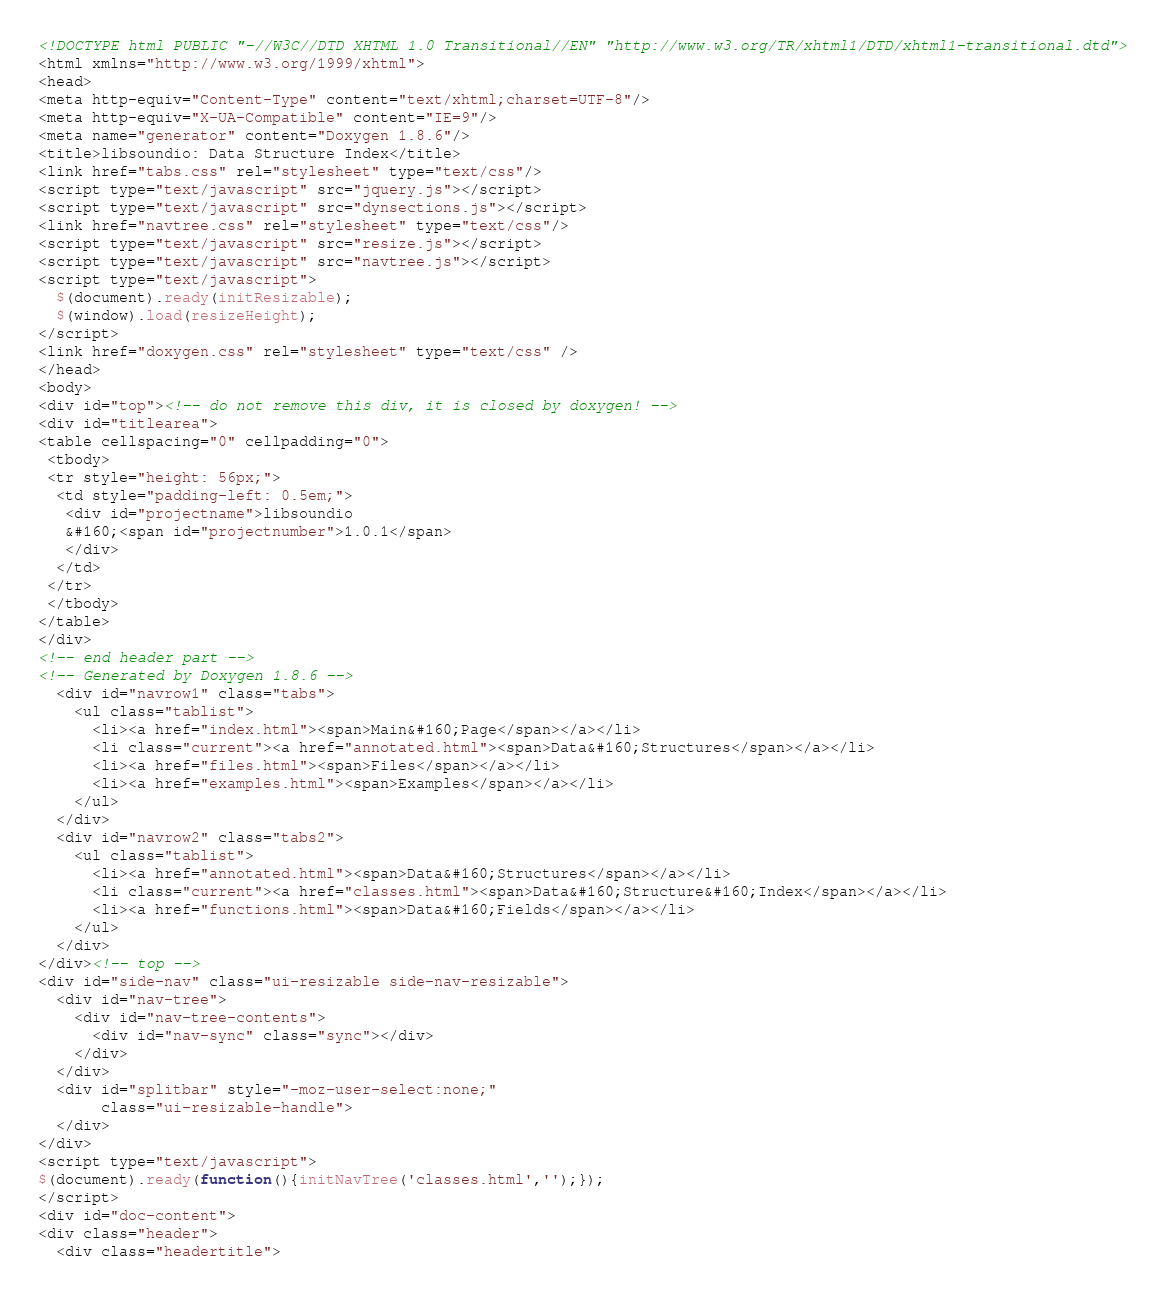<code> <loc_0><loc_0><loc_500><loc_500><_HTML_><!DOCTYPE html PUBLIC "-//W3C//DTD XHTML 1.0 Transitional//EN" "http://www.w3.org/TR/xhtml1/DTD/xhtml1-transitional.dtd">
<html xmlns="http://www.w3.org/1999/xhtml">
<head>
<meta http-equiv="Content-Type" content="text/xhtml;charset=UTF-8"/>
<meta http-equiv="X-UA-Compatible" content="IE=9"/>
<meta name="generator" content="Doxygen 1.8.6"/>
<title>libsoundio: Data Structure Index</title>
<link href="tabs.css" rel="stylesheet" type="text/css"/>
<script type="text/javascript" src="jquery.js"></script>
<script type="text/javascript" src="dynsections.js"></script>
<link href="navtree.css" rel="stylesheet" type="text/css"/>
<script type="text/javascript" src="resize.js"></script>
<script type="text/javascript" src="navtree.js"></script>
<script type="text/javascript">
  $(document).ready(initResizable);
  $(window).load(resizeHeight);
</script>
<link href="doxygen.css" rel="stylesheet" type="text/css" />
</head>
<body>
<div id="top"><!-- do not remove this div, it is closed by doxygen! -->
<div id="titlearea">
<table cellspacing="0" cellpadding="0">
 <tbody>
 <tr style="height: 56px;">
  <td style="padding-left: 0.5em;">
   <div id="projectname">libsoundio
   &#160;<span id="projectnumber">1.0.1</span>
   </div>
  </td>
 </tr>
 </tbody>
</table>
</div>
<!-- end header part -->
<!-- Generated by Doxygen 1.8.6 -->
  <div id="navrow1" class="tabs">
    <ul class="tablist">
      <li><a href="index.html"><span>Main&#160;Page</span></a></li>
      <li class="current"><a href="annotated.html"><span>Data&#160;Structures</span></a></li>
      <li><a href="files.html"><span>Files</span></a></li>
      <li><a href="examples.html"><span>Examples</span></a></li>
    </ul>
  </div>
  <div id="navrow2" class="tabs2">
    <ul class="tablist">
      <li><a href="annotated.html"><span>Data&#160;Structures</span></a></li>
      <li class="current"><a href="classes.html"><span>Data&#160;Structure&#160;Index</span></a></li>
      <li><a href="functions.html"><span>Data&#160;Fields</span></a></li>
    </ul>
  </div>
</div><!-- top -->
<div id="side-nav" class="ui-resizable side-nav-resizable">
  <div id="nav-tree">
    <div id="nav-tree-contents">
      <div id="nav-sync" class="sync"></div>
    </div>
  </div>
  <div id="splitbar" style="-moz-user-select:none;" 
       class="ui-resizable-handle">
  </div>
</div>
<script type="text/javascript">
$(document).ready(function(){initNavTree('classes.html','');});
</script>
<div id="doc-content">
<div class="header">
  <div class="headertitle"></code> 